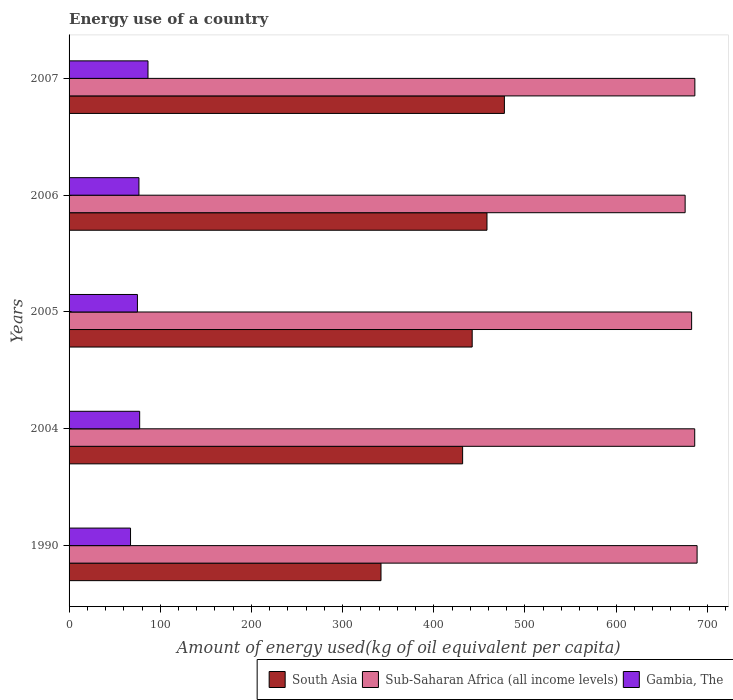How many different coloured bars are there?
Offer a terse response. 3. How many groups of bars are there?
Provide a succinct answer. 5. Are the number of bars per tick equal to the number of legend labels?
Provide a short and direct response. Yes. Are the number of bars on each tick of the Y-axis equal?
Your response must be concise. Yes. In how many cases, is the number of bars for a given year not equal to the number of legend labels?
Provide a short and direct response. 0. What is the amount of energy used in in South Asia in 1990?
Your answer should be very brief. 342.11. Across all years, what is the maximum amount of energy used in in South Asia?
Give a very brief answer. 477.44. Across all years, what is the minimum amount of energy used in in South Asia?
Offer a very short reply. 342.11. In which year was the amount of energy used in in South Asia maximum?
Keep it short and to the point. 2007. In which year was the amount of energy used in in Gambia, The minimum?
Provide a short and direct response. 1990. What is the total amount of energy used in in Sub-Saharan Africa (all income levels) in the graph?
Your response must be concise. 3419.75. What is the difference between the amount of energy used in in Gambia, The in 1990 and that in 2007?
Your answer should be compact. -19.17. What is the difference between the amount of energy used in in Sub-Saharan Africa (all income levels) in 1990 and the amount of energy used in in South Asia in 2007?
Make the answer very short. 211.34. What is the average amount of energy used in in Gambia, The per year?
Offer a terse response. 76.6. In the year 2006, what is the difference between the amount of energy used in in Sub-Saharan Africa (all income levels) and amount of energy used in in South Asia?
Provide a succinct answer. 217.33. What is the ratio of the amount of energy used in in South Asia in 2004 to that in 2007?
Your answer should be compact. 0.9. What is the difference between the highest and the second highest amount of energy used in in Gambia, The?
Make the answer very short. 9.13. What is the difference between the highest and the lowest amount of energy used in in South Asia?
Provide a succinct answer. 135.33. In how many years, is the amount of energy used in in Gambia, The greater than the average amount of energy used in in Gambia, The taken over all years?
Offer a terse response. 3. Is the sum of the amount of energy used in in Sub-Saharan Africa (all income levels) in 1990 and 2004 greater than the maximum amount of energy used in in Gambia, The across all years?
Offer a terse response. Yes. What does the 1st bar from the top in 2007 represents?
Offer a terse response. Gambia, The. What does the 3rd bar from the bottom in 1990 represents?
Offer a terse response. Gambia, The. How many bars are there?
Ensure brevity in your answer.  15. How many years are there in the graph?
Give a very brief answer. 5. What is the difference between two consecutive major ticks on the X-axis?
Provide a succinct answer. 100. Does the graph contain any zero values?
Your answer should be compact. No. Where does the legend appear in the graph?
Ensure brevity in your answer.  Bottom right. What is the title of the graph?
Give a very brief answer. Energy use of a country. What is the label or title of the X-axis?
Keep it short and to the point. Amount of energy used(kg of oil equivalent per capita). What is the label or title of the Y-axis?
Your answer should be compact. Years. What is the Amount of energy used(kg of oil equivalent per capita) in South Asia in 1990?
Offer a terse response. 342.11. What is the Amount of energy used(kg of oil equivalent per capita) of Sub-Saharan Africa (all income levels) in 1990?
Your answer should be very brief. 688.78. What is the Amount of energy used(kg of oil equivalent per capita) of Gambia, The in 1990?
Ensure brevity in your answer.  67.4. What is the Amount of energy used(kg of oil equivalent per capita) in South Asia in 2004?
Provide a succinct answer. 431.64. What is the Amount of energy used(kg of oil equivalent per capita) in Sub-Saharan Africa (all income levels) in 2004?
Keep it short and to the point. 686.17. What is the Amount of energy used(kg of oil equivalent per capita) of Gambia, The in 2004?
Your answer should be compact. 77.43. What is the Amount of energy used(kg of oil equivalent per capita) in South Asia in 2005?
Offer a terse response. 442.12. What is the Amount of energy used(kg of oil equivalent per capita) of Sub-Saharan Africa (all income levels) in 2005?
Provide a short and direct response. 682.79. What is the Amount of energy used(kg of oil equivalent per capita) of Gambia, The in 2005?
Your response must be concise. 74.97. What is the Amount of energy used(kg of oil equivalent per capita) in South Asia in 2006?
Give a very brief answer. 458.34. What is the Amount of energy used(kg of oil equivalent per capita) of Sub-Saharan Africa (all income levels) in 2006?
Offer a very short reply. 675.67. What is the Amount of energy used(kg of oil equivalent per capita) in Gambia, The in 2006?
Give a very brief answer. 76.63. What is the Amount of energy used(kg of oil equivalent per capita) in South Asia in 2007?
Make the answer very short. 477.44. What is the Amount of energy used(kg of oil equivalent per capita) in Sub-Saharan Africa (all income levels) in 2007?
Offer a very short reply. 686.34. What is the Amount of energy used(kg of oil equivalent per capita) of Gambia, The in 2007?
Give a very brief answer. 86.56. Across all years, what is the maximum Amount of energy used(kg of oil equivalent per capita) in South Asia?
Provide a short and direct response. 477.44. Across all years, what is the maximum Amount of energy used(kg of oil equivalent per capita) in Sub-Saharan Africa (all income levels)?
Your response must be concise. 688.78. Across all years, what is the maximum Amount of energy used(kg of oil equivalent per capita) of Gambia, The?
Your answer should be compact. 86.56. Across all years, what is the minimum Amount of energy used(kg of oil equivalent per capita) of South Asia?
Ensure brevity in your answer.  342.11. Across all years, what is the minimum Amount of energy used(kg of oil equivalent per capita) in Sub-Saharan Africa (all income levels)?
Make the answer very short. 675.67. Across all years, what is the minimum Amount of energy used(kg of oil equivalent per capita) in Gambia, The?
Make the answer very short. 67.4. What is the total Amount of energy used(kg of oil equivalent per capita) in South Asia in the graph?
Keep it short and to the point. 2151.65. What is the total Amount of energy used(kg of oil equivalent per capita) in Sub-Saharan Africa (all income levels) in the graph?
Give a very brief answer. 3419.75. What is the total Amount of energy used(kg of oil equivalent per capita) in Gambia, The in the graph?
Offer a very short reply. 383. What is the difference between the Amount of energy used(kg of oil equivalent per capita) of South Asia in 1990 and that in 2004?
Give a very brief answer. -89.53. What is the difference between the Amount of energy used(kg of oil equivalent per capita) in Sub-Saharan Africa (all income levels) in 1990 and that in 2004?
Give a very brief answer. 2.61. What is the difference between the Amount of energy used(kg of oil equivalent per capita) of Gambia, The in 1990 and that in 2004?
Offer a very short reply. -10.04. What is the difference between the Amount of energy used(kg of oil equivalent per capita) in South Asia in 1990 and that in 2005?
Ensure brevity in your answer.  -100.01. What is the difference between the Amount of energy used(kg of oil equivalent per capita) in Sub-Saharan Africa (all income levels) in 1990 and that in 2005?
Your answer should be compact. 5.99. What is the difference between the Amount of energy used(kg of oil equivalent per capita) of Gambia, The in 1990 and that in 2005?
Give a very brief answer. -7.57. What is the difference between the Amount of energy used(kg of oil equivalent per capita) in South Asia in 1990 and that in 2006?
Keep it short and to the point. -116.23. What is the difference between the Amount of energy used(kg of oil equivalent per capita) in Sub-Saharan Africa (all income levels) in 1990 and that in 2006?
Provide a short and direct response. 13.11. What is the difference between the Amount of energy used(kg of oil equivalent per capita) in Gambia, The in 1990 and that in 2006?
Provide a short and direct response. -9.23. What is the difference between the Amount of energy used(kg of oil equivalent per capita) of South Asia in 1990 and that in 2007?
Give a very brief answer. -135.33. What is the difference between the Amount of energy used(kg of oil equivalent per capita) in Sub-Saharan Africa (all income levels) in 1990 and that in 2007?
Your answer should be compact. 2.45. What is the difference between the Amount of energy used(kg of oil equivalent per capita) in Gambia, The in 1990 and that in 2007?
Your answer should be very brief. -19.17. What is the difference between the Amount of energy used(kg of oil equivalent per capita) in South Asia in 2004 and that in 2005?
Provide a short and direct response. -10.48. What is the difference between the Amount of energy used(kg of oil equivalent per capita) of Sub-Saharan Africa (all income levels) in 2004 and that in 2005?
Offer a very short reply. 3.38. What is the difference between the Amount of energy used(kg of oil equivalent per capita) of Gambia, The in 2004 and that in 2005?
Make the answer very short. 2.46. What is the difference between the Amount of energy used(kg of oil equivalent per capita) in South Asia in 2004 and that in 2006?
Your answer should be compact. -26.7. What is the difference between the Amount of energy used(kg of oil equivalent per capita) in Sub-Saharan Africa (all income levels) in 2004 and that in 2006?
Your answer should be very brief. 10.51. What is the difference between the Amount of energy used(kg of oil equivalent per capita) in Gambia, The in 2004 and that in 2006?
Offer a very short reply. 0.81. What is the difference between the Amount of energy used(kg of oil equivalent per capita) of South Asia in 2004 and that in 2007?
Make the answer very short. -45.81. What is the difference between the Amount of energy used(kg of oil equivalent per capita) in Sub-Saharan Africa (all income levels) in 2004 and that in 2007?
Keep it short and to the point. -0.16. What is the difference between the Amount of energy used(kg of oil equivalent per capita) of Gambia, The in 2004 and that in 2007?
Your response must be concise. -9.13. What is the difference between the Amount of energy used(kg of oil equivalent per capita) in South Asia in 2005 and that in 2006?
Your answer should be compact. -16.22. What is the difference between the Amount of energy used(kg of oil equivalent per capita) of Sub-Saharan Africa (all income levels) in 2005 and that in 2006?
Offer a terse response. 7.12. What is the difference between the Amount of energy used(kg of oil equivalent per capita) in Gambia, The in 2005 and that in 2006?
Offer a terse response. -1.66. What is the difference between the Amount of energy used(kg of oil equivalent per capita) in South Asia in 2005 and that in 2007?
Give a very brief answer. -35.32. What is the difference between the Amount of energy used(kg of oil equivalent per capita) of Sub-Saharan Africa (all income levels) in 2005 and that in 2007?
Your response must be concise. -3.54. What is the difference between the Amount of energy used(kg of oil equivalent per capita) in Gambia, The in 2005 and that in 2007?
Ensure brevity in your answer.  -11.59. What is the difference between the Amount of energy used(kg of oil equivalent per capita) in South Asia in 2006 and that in 2007?
Offer a terse response. -19.1. What is the difference between the Amount of energy used(kg of oil equivalent per capita) in Sub-Saharan Africa (all income levels) in 2006 and that in 2007?
Offer a very short reply. -10.67. What is the difference between the Amount of energy used(kg of oil equivalent per capita) in Gambia, The in 2006 and that in 2007?
Make the answer very short. -9.94. What is the difference between the Amount of energy used(kg of oil equivalent per capita) of South Asia in 1990 and the Amount of energy used(kg of oil equivalent per capita) of Sub-Saharan Africa (all income levels) in 2004?
Your answer should be very brief. -344.06. What is the difference between the Amount of energy used(kg of oil equivalent per capita) of South Asia in 1990 and the Amount of energy used(kg of oil equivalent per capita) of Gambia, The in 2004?
Offer a very short reply. 264.67. What is the difference between the Amount of energy used(kg of oil equivalent per capita) of Sub-Saharan Africa (all income levels) in 1990 and the Amount of energy used(kg of oil equivalent per capita) of Gambia, The in 2004?
Your answer should be compact. 611.35. What is the difference between the Amount of energy used(kg of oil equivalent per capita) of South Asia in 1990 and the Amount of energy used(kg of oil equivalent per capita) of Sub-Saharan Africa (all income levels) in 2005?
Your answer should be very brief. -340.68. What is the difference between the Amount of energy used(kg of oil equivalent per capita) of South Asia in 1990 and the Amount of energy used(kg of oil equivalent per capita) of Gambia, The in 2005?
Offer a terse response. 267.14. What is the difference between the Amount of energy used(kg of oil equivalent per capita) of Sub-Saharan Africa (all income levels) in 1990 and the Amount of energy used(kg of oil equivalent per capita) of Gambia, The in 2005?
Give a very brief answer. 613.81. What is the difference between the Amount of energy used(kg of oil equivalent per capita) of South Asia in 1990 and the Amount of energy used(kg of oil equivalent per capita) of Sub-Saharan Africa (all income levels) in 2006?
Keep it short and to the point. -333.56. What is the difference between the Amount of energy used(kg of oil equivalent per capita) of South Asia in 1990 and the Amount of energy used(kg of oil equivalent per capita) of Gambia, The in 2006?
Give a very brief answer. 265.48. What is the difference between the Amount of energy used(kg of oil equivalent per capita) of Sub-Saharan Africa (all income levels) in 1990 and the Amount of energy used(kg of oil equivalent per capita) of Gambia, The in 2006?
Offer a terse response. 612.16. What is the difference between the Amount of energy used(kg of oil equivalent per capita) in South Asia in 1990 and the Amount of energy used(kg of oil equivalent per capita) in Sub-Saharan Africa (all income levels) in 2007?
Offer a terse response. -344.23. What is the difference between the Amount of energy used(kg of oil equivalent per capita) of South Asia in 1990 and the Amount of energy used(kg of oil equivalent per capita) of Gambia, The in 2007?
Offer a terse response. 255.54. What is the difference between the Amount of energy used(kg of oil equivalent per capita) of Sub-Saharan Africa (all income levels) in 1990 and the Amount of energy used(kg of oil equivalent per capita) of Gambia, The in 2007?
Keep it short and to the point. 602.22. What is the difference between the Amount of energy used(kg of oil equivalent per capita) of South Asia in 2004 and the Amount of energy used(kg of oil equivalent per capita) of Sub-Saharan Africa (all income levels) in 2005?
Make the answer very short. -251.16. What is the difference between the Amount of energy used(kg of oil equivalent per capita) of South Asia in 2004 and the Amount of energy used(kg of oil equivalent per capita) of Gambia, The in 2005?
Your answer should be very brief. 356.67. What is the difference between the Amount of energy used(kg of oil equivalent per capita) of Sub-Saharan Africa (all income levels) in 2004 and the Amount of energy used(kg of oil equivalent per capita) of Gambia, The in 2005?
Your answer should be compact. 611.2. What is the difference between the Amount of energy used(kg of oil equivalent per capita) of South Asia in 2004 and the Amount of energy used(kg of oil equivalent per capita) of Sub-Saharan Africa (all income levels) in 2006?
Make the answer very short. -244.03. What is the difference between the Amount of energy used(kg of oil equivalent per capita) in South Asia in 2004 and the Amount of energy used(kg of oil equivalent per capita) in Gambia, The in 2006?
Your response must be concise. 355.01. What is the difference between the Amount of energy used(kg of oil equivalent per capita) in Sub-Saharan Africa (all income levels) in 2004 and the Amount of energy used(kg of oil equivalent per capita) in Gambia, The in 2006?
Keep it short and to the point. 609.55. What is the difference between the Amount of energy used(kg of oil equivalent per capita) of South Asia in 2004 and the Amount of energy used(kg of oil equivalent per capita) of Sub-Saharan Africa (all income levels) in 2007?
Offer a very short reply. -254.7. What is the difference between the Amount of energy used(kg of oil equivalent per capita) in South Asia in 2004 and the Amount of energy used(kg of oil equivalent per capita) in Gambia, The in 2007?
Provide a short and direct response. 345.07. What is the difference between the Amount of energy used(kg of oil equivalent per capita) of Sub-Saharan Africa (all income levels) in 2004 and the Amount of energy used(kg of oil equivalent per capita) of Gambia, The in 2007?
Ensure brevity in your answer.  599.61. What is the difference between the Amount of energy used(kg of oil equivalent per capita) in South Asia in 2005 and the Amount of energy used(kg of oil equivalent per capita) in Sub-Saharan Africa (all income levels) in 2006?
Your answer should be compact. -233.55. What is the difference between the Amount of energy used(kg of oil equivalent per capita) in South Asia in 2005 and the Amount of energy used(kg of oil equivalent per capita) in Gambia, The in 2006?
Keep it short and to the point. 365.49. What is the difference between the Amount of energy used(kg of oil equivalent per capita) of Sub-Saharan Africa (all income levels) in 2005 and the Amount of energy used(kg of oil equivalent per capita) of Gambia, The in 2006?
Give a very brief answer. 606.17. What is the difference between the Amount of energy used(kg of oil equivalent per capita) in South Asia in 2005 and the Amount of energy used(kg of oil equivalent per capita) in Sub-Saharan Africa (all income levels) in 2007?
Offer a terse response. -244.21. What is the difference between the Amount of energy used(kg of oil equivalent per capita) of South Asia in 2005 and the Amount of energy used(kg of oil equivalent per capita) of Gambia, The in 2007?
Provide a short and direct response. 355.56. What is the difference between the Amount of energy used(kg of oil equivalent per capita) of Sub-Saharan Africa (all income levels) in 2005 and the Amount of energy used(kg of oil equivalent per capita) of Gambia, The in 2007?
Offer a terse response. 596.23. What is the difference between the Amount of energy used(kg of oil equivalent per capita) of South Asia in 2006 and the Amount of energy used(kg of oil equivalent per capita) of Sub-Saharan Africa (all income levels) in 2007?
Give a very brief answer. -228. What is the difference between the Amount of energy used(kg of oil equivalent per capita) of South Asia in 2006 and the Amount of energy used(kg of oil equivalent per capita) of Gambia, The in 2007?
Make the answer very short. 371.78. What is the difference between the Amount of energy used(kg of oil equivalent per capita) of Sub-Saharan Africa (all income levels) in 2006 and the Amount of energy used(kg of oil equivalent per capita) of Gambia, The in 2007?
Keep it short and to the point. 589.1. What is the average Amount of energy used(kg of oil equivalent per capita) of South Asia per year?
Your response must be concise. 430.33. What is the average Amount of energy used(kg of oil equivalent per capita) in Sub-Saharan Africa (all income levels) per year?
Your answer should be compact. 683.95. What is the average Amount of energy used(kg of oil equivalent per capita) in Gambia, The per year?
Give a very brief answer. 76.6. In the year 1990, what is the difference between the Amount of energy used(kg of oil equivalent per capita) of South Asia and Amount of energy used(kg of oil equivalent per capita) of Sub-Saharan Africa (all income levels)?
Provide a succinct answer. -346.67. In the year 1990, what is the difference between the Amount of energy used(kg of oil equivalent per capita) in South Asia and Amount of energy used(kg of oil equivalent per capita) in Gambia, The?
Your response must be concise. 274.71. In the year 1990, what is the difference between the Amount of energy used(kg of oil equivalent per capita) in Sub-Saharan Africa (all income levels) and Amount of energy used(kg of oil equivalent per capita) in Gambia, The?
Give a very brief answer. 621.38. In the year 2004, what is the difference between the Amount of energy used(kg of oil equivalent per capita) of South Asia and Amount of energy used(kg of oil equivalent per capita) of Sub-Saharan Africa (all income levels)?
Make the answer very short. -254.54. In the year 2004, what is the difference between the Amount of energy used(kg of oil equivalent per capita) in South Asia and Amount of energy used(kg of oil equivalent per capita) in Gambia, The?
Provide a short and direct response. 354.2. In the year 2004, what is the difference between the Amount of energy used(kg of oil equivalent per capita) in Sub-Saharan Africa (all income levels) and Amount of energy used(kg of oil equivalent per capita) in Gambia, The?
Provide a short and direct response. 608.74. In the year 2005, what is the difference between the Amount of energy used(kg of oil equivalent per capita) in South Asia and Amount of energy used(kg of oil equivalent per capita) in Sub-Saharan Africa (all income levels)?
Your answer should be compact. -240.67. In the year 2005, what is the difference between the Amount of energy used(kg of oil equivalent per capita) of South Asia and Amount of energy used(kg of oil equivalent per capita) of Gambia, The?
Make the answer very short. 367.15. In the year 2005, what is the difference between the Amount of energy used(kg of oil equivalent per capita) in Sub-Saharan Africa (all income levels) and Amount of energy used(kg of oil equivalent per capita) in Gambia, The?
Provide a short and direct response. 607.82. In the year 2006, what is the difference between the Amount of energy used(kg of oil equivalent per capita) of South Asia and Amount of energy used(kg of oil equivalent per capita) of Sub-Saharan Africa (all income levels)?
Keep it short and to the point. -217.33. In the year 2006, what is the difference between the Amount of energy used(kg of oil equivalent per capita) in South Asia and Amount of energy used(kg of oil equivalent per capita) in Gambia, The?
Your response must be concise. 381.71. In the year 2006, what is the difference between the Amount of energy used(kg of oil equivalent per capita) in Sub-Saharan Africa (all income levels) and Amount of energy used(kg of oil equivalent per capita) in Gambia, The?
Provide a succinct answer. 599.04. In the year 2007, what is the difference between the Amount of energy used(kg of oil equivalent per capita) of South Asia and Amount of energy used(kg of oil equivalent per capita) of Sub-Saharan Africa (all income levels)?
Ensure brevity in your answer.  -208.89. In the year 2007, what is the difference between the Amount of energy used(kg of oil equivalent per capita) in South Asia and Amount of energy used(kg of oil equivalent per capita) in Gambia, The?
Offer a very short reply. 390.88. In the year 2007, what is the difference between the Amount of energy used(kg of oil equivalent per capita) in Sub-Saharan Africa (all income levels) and Amount of energy used(kg of oil equivalent per capita) in Gambia, The?
Your response must be concise. 599.77. What is the ratio of the Amount of energy used(kg of oil equivalent per capita) of South Asia in 1990 to that in 2004?
Your response must be concise. 0.79. What is the ratio of the Amount of energy used(kg of oil equivalent per capita) in Sub-Saharan Africa (all income levels) in 1990 to that in 2004?
Your answer should be very brief. 1. What is the ratio of the Amount of energy used(kg of oil equivalent per capita) in Gambia, The in 1990 to that in 2004?
Keep it short and to the point. 0.87. What is the ratio of the Amount of energy used(kg of oil equivalent per capita) in South Asia in 1990 to that in 2005?
Give a very brief answer. 0.77. What is the ratio of the Amount of energy used(kg of oil equivalent per capita) in Sub-Saharan Africa (all income levels) in 1990 to that in 2005?
Your answer should be compact. 1.01. What is the ratio of the Amount of energy used(kg of oil equivalent per capita) of Gambia, The in 1990 to that in 2005?
Your answer should be compact. 0.9. What is the ratio of the Amount of energy used(kg of oil equivalent per capita) in South Asia in 1990 to that in 2006?
Give a very brief answer. 0.75. What is the ratio of the Amount of energy used(kg of oil equivalent per capita) of Sub-Saharan Africa (all income levels) in 1990 to that in 2006?
Ensure brevity in your answer.  1.02. What is the ratio of the Amount of energy used(kg of oil equivalent per capita) in Gambia, The in 1990 to that in 2006?
Make the answer very short. 0.88. What is the ratio of the Amount of energy used(kg of oil equivalent per capita) of South Asia in 1990 to that in 2007?
Give a very brief answer. 0.72. What is the ratio of the Amount of energy used(kg of oil equivalent per capita) of Sub-Saharan Africa (all income levels) in 1990 to that in 2007?
Ensure brevity in your answer.  1. What is the ratio of the Amount of energy used(kg of oil equivalent per capita) of Gambia, The in 1990 to that in 2007?
Give a very brief answer. 0.78. What is the ratio of the Amount of energy used(kg of oil equivalent per capita) in South Asia in 2004 to that in 2005?
Your response must be concise. 0.98. What is the ratio of the Amount of energy used(kg of oil equivalent per capita) of Sub-Saharan Africa (all income levels) in 2004 to that in 2005?
Make the answer very short. 1. What is the ratio of the Amount of energy used(kg of oil equivalent per capita) in Gambia, The in 2004 to that in 2005?
Keep it short and to the point. 1.03. What is the ratio of the Amount of energy used(kg of oil equivalent per capita) of South Asia in 2004 to that in 2006?
Ensure brevity in your answer.  0.94. What is the ratio of the Amount of energy used(kg of oil equivalent per capita) of Sub-Saharan Africa (all income levels) in 2004 to that in 2006?
Give a very brief answer. 1.02. What is the ratio of the Amount of energy used(kg of oil equivalent per capita) in Gambia, The in 2004 to that in 2006?
Provide a succinct answer. 1.01. What is the ratio of the Amount of energy used(kg of oil equivalent per capita) of South Asia in 2004 to that in 2007?
Your answer should be very brief. 0.9. What is the ratio of the Amount of energy used(kg of oil equivalent per capita) of Sub-Saharan Africa (all income levels) in 2004 to that in 2007?
Make the answer very short. 1. What is the ratio of the Amount of energy used(kg of oil equivalent per capita) of Gambia, The in 2004 to that in 2007?
Keep it short and to the point. 0.89. What is the ratio of the Amount of energy used(kg of oil equivalent per capita) of South Asia in 2005 to that in 2006?
Keep it short and to the point. 0.96. What is the ratio of the Amount of energy used(kg of oil equivalent per capita) in Sub-Saharan Africa (all income levels) in 2005 to that in 2006?
Offer a terse response. 1.01. What is the ratio of the Amount of energy used(kg of oil equivalent per capita) of Gambia, The in 2005 to that in 2006?
Ensure brevity in your answer.  0.98. What is the ratio of the Amount of energy used(kg of oil equivalent per capita) in South Asia in 2005 to that in 2007?
Provide a short and direct response. 0.93. What is the ratio of the Amount of energy used(kg of oil equivalent per capita) of Sub-Saharan Africa (all income levels) in 2005 to that in 2007?
Provide a short and direct response. 0.99. What is the ratio of the Amount of energy used(kg of oil equivalent per capita) of Gambia, The in 2005 to that in 2007?
Your response must be concise. 0.87. What is the ratio of the Amount of energy used(kg of oil equivalent per capita) in Sub-Saharan Africa (all income levels) in 2006 to that in 2007?
Offer a very short reply. 0.98. What is the ratio of the Amount of energy used(kg of oil equivalent per capita) of Gambia, The in 2006 to that in 2007?
Give a very brief answer. 0.89. What is the difference between the highest and the second highest Amount of energy used(kg of oil equivalent per capita) in South Asia?
Keep it short and to the point. 19.1. What is the difference between the highest and the second highest Amount of energy used(kg of oil equivalent per capita) of Sub-Saharan Africa (all income levels)?
Make the answer very short. 2.45. What is the difference between the highest and the second highest Amount of energy used(kg of oil equivalent per capita) in Gambia, The?
Keep it short and to the point. 9.13. What is the difference between the highest and the lowest Amount of energy used(kg of oil equivalent per capita) in South Asia?
Make the answer very short. 135.33. What is the difference between the highest and the lowest Amount of energy used(kg of oil equivalent per capita) of Sub-Saharan Africa (all income levels)?
Offer a very short reply. 13.11. What is the difference between the highest and the lowest Amount of energy used(kg of oil equivalent per capita) in Gambia, The?
Your response must be concise. 19.17. 